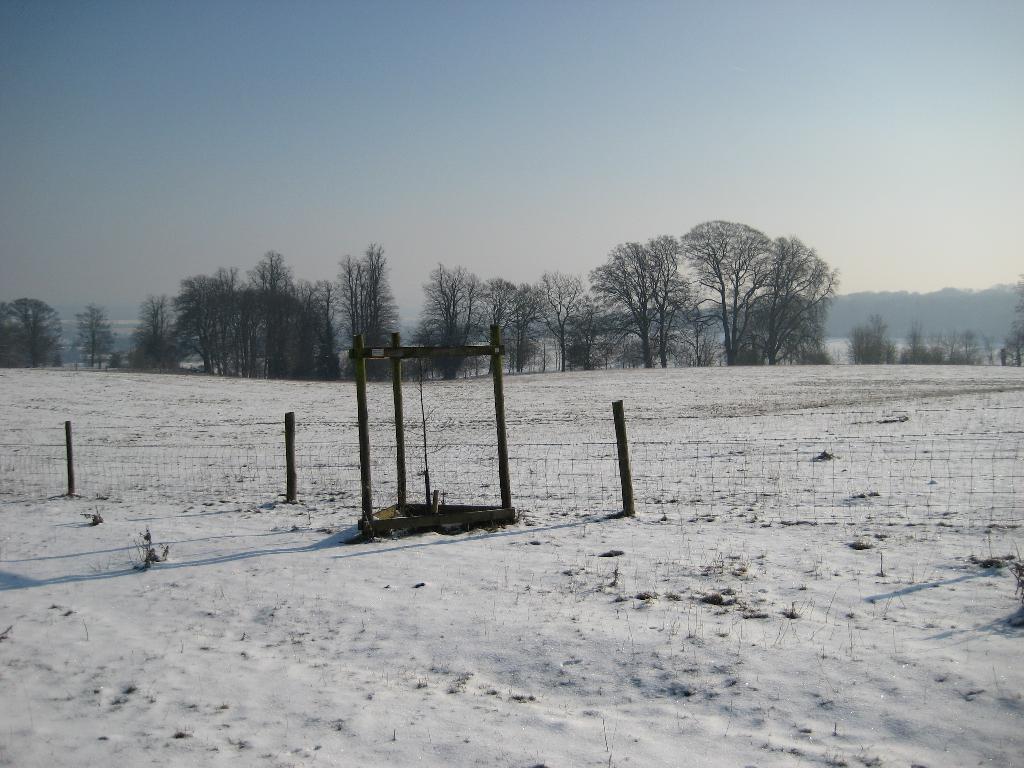Could you give a brief overview of what you see in this image? In the image there is a land covered with a lot of snow, there is a fencing in between the land and in the background there are many trees and behind the trees there are mountains. 